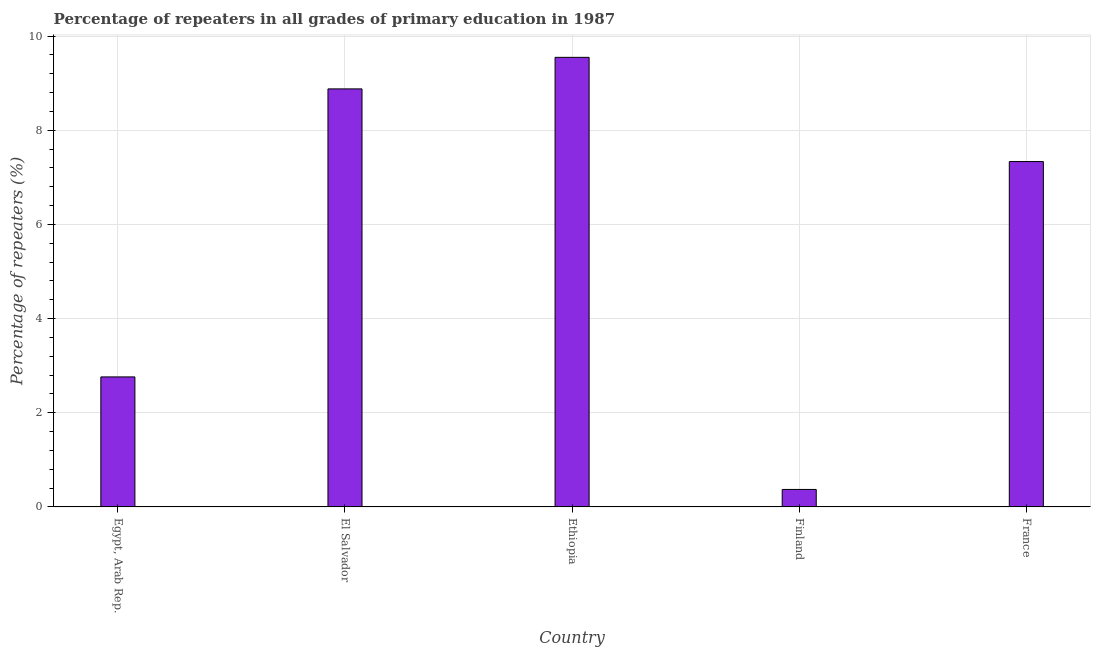Does the graph contain grids?
Provide a short and direct response. Yes. What is the title of the graph?
Give a very brief answer. Percentage of repeaters in all grades of primary education in 1987. What is the label or title of the X-axis?
Offer a very short reply. Country. What is the label or title of the Y-axis?
Your answer should be compact. Percentage of repeaters (%). What is the percentage of repeaters in primary education in France?
Keep it short and to the point. 7.33. Across all countries, what is the maximum percentage of repeaters in primary education?
Offer a very short reply. 9.55. Across all countries, what is the minimum percentage of repeaters in primary education?
Give a very brief answer. 0.37. In which country was the percentage of repeaters in primary education maximum?
Provide a succinct answer. Ethiopia. What is the sum of the percentage of repeaters in primary education?
Keep it short and to the point. 28.89. What is the difference between the percentage of repeaters in primary education in Egypt, Arab Rep. and France?
Ensure brevity in your answer.  -4.57. What is the average percentage of repeaters in primary education per country?
Your response must be concise. 5.78. What is the median percentage of repeaters in primary education?
Offer a terse response. 7.33. What is the ratio of the percentage of repeaters in primary education in Egypt, Arab Rep. to that in France?
Keep it short and to the point. 0.38. What is the difference between the highest and the second highest percentage of repeaters in primary education?
Offer a terse response. 0.67. What is the difference between the highest and the lowest percentage of repeaters in primary education?
Keep it short and to the point. 9.18. How many bars are there?
Ensure brevity in your answer.  5. Are all the bars in the graph horizontal?
Provide a short and direct response. No. How many countries are there in the graph?
Offer a terse response. 5. What is the difference between two consecutive major ticks on the Y-axis?
Your answer should be very brief. 2. What is the Percentage of repeaters (%) of Egypt, Arab Rep.?
Offer a very short reply. 2.76. What is the Percentage of repeaters (%) in El Salvador?
Ensure brevity in your answer.  8.88. What is the Percentage of repeaters (%) of Ethiopia?
Provide a short and direct response. 9.55. What is the Percentage of repeaters (%) in Finland?
Keep it short and to the point. 0.37. What is the Percentage of repeaters (%) of France?
Give a very brief answer. 7.33. What is the difference between the Percentage of repeaters (%) in Egypt, Arab Rep. and El Salvador?
Provide a short and direct response. -6.12. What is the difference between the Percentage of repeaters (%) in Egypt, Arab Rep. and Ethiopia?
Make the answer very short. -6.79. What is the difference between the Percentage of repeaters (%) in Egypt, Arab Rep. and Finland?
Your answer should be very brief. 2.39. What is the difference between the Percentage of repeaters (%) in Egypt, Arab Rep. and France?
Give a very brief answer. -4.57. What is the difference between the Percentage of repeaters (%) in El Salvador and Ethiopia?
Keep it short and to the point. -0.67. What is the difference between the Percentage of repeaters (%) in El Salvador and Finland?
Your answer should be very brief. 8.51. What is the difference between the Percentage of repeaters (%) in El Salvador and France?
Your answer should be very brief. 1.54. What is the difference between the Percentage of repeaters (%) in Ethiopia and Finland?
Provide a short and direct response. 9.18. What is the difference between the Percentage of repeaters (%) in Ethiopia and France?
Provide a short and direct response. 2.21. What is the difference between the Percentage of repeaters (%) in Finland and France?
Make the answer very short. -6.96. What is the ratio of the Percentage of repeaters (%) in Egypt, Arab Rep. to that in El Salvador?
Your response must be concise. 0.31. What is the ratio of the Percentage of repeaters (%) in Egypt, Arab Rep. to that in Ethiopia?
Offer a very short reply. 0.29. What is the ratio of the Percentage of repeaters (%) in Egypt, Arab Rep. to that in Finland?
Provide a succinct answer. 7.44. What is the ratio of the Percentage of repeaters (%) in Egypt, Arab Rep. to that in France?
Your answer should be compact. 0.38. What is the ratio of the Percentage of repeaters (%) in El Salvador to that in Ethiopia?
Provide a short and direct response. 0.93. What is the ratio of the Percentage of repeaters (%) in El Salvador to that in Finland?
Your answer should be very brief. 23.92. What is the ratio of the Percentage of repeaters (%) in El Salvador to that in France?
Offer a very short reply. 1.21. What is the ratio of the Percentage of repeaters (%) in Ethiopia to that in Finland?
Give a very brief answer. 25.72. What is the ratio of the Percentage of repeaters (%) in Ethiopia to that in France?
Your response must be concise. 1.3. What is the ratio of the Percentage of repeaters (%) in Finland to that in France?
Provide a succinct answer. 0.05. 